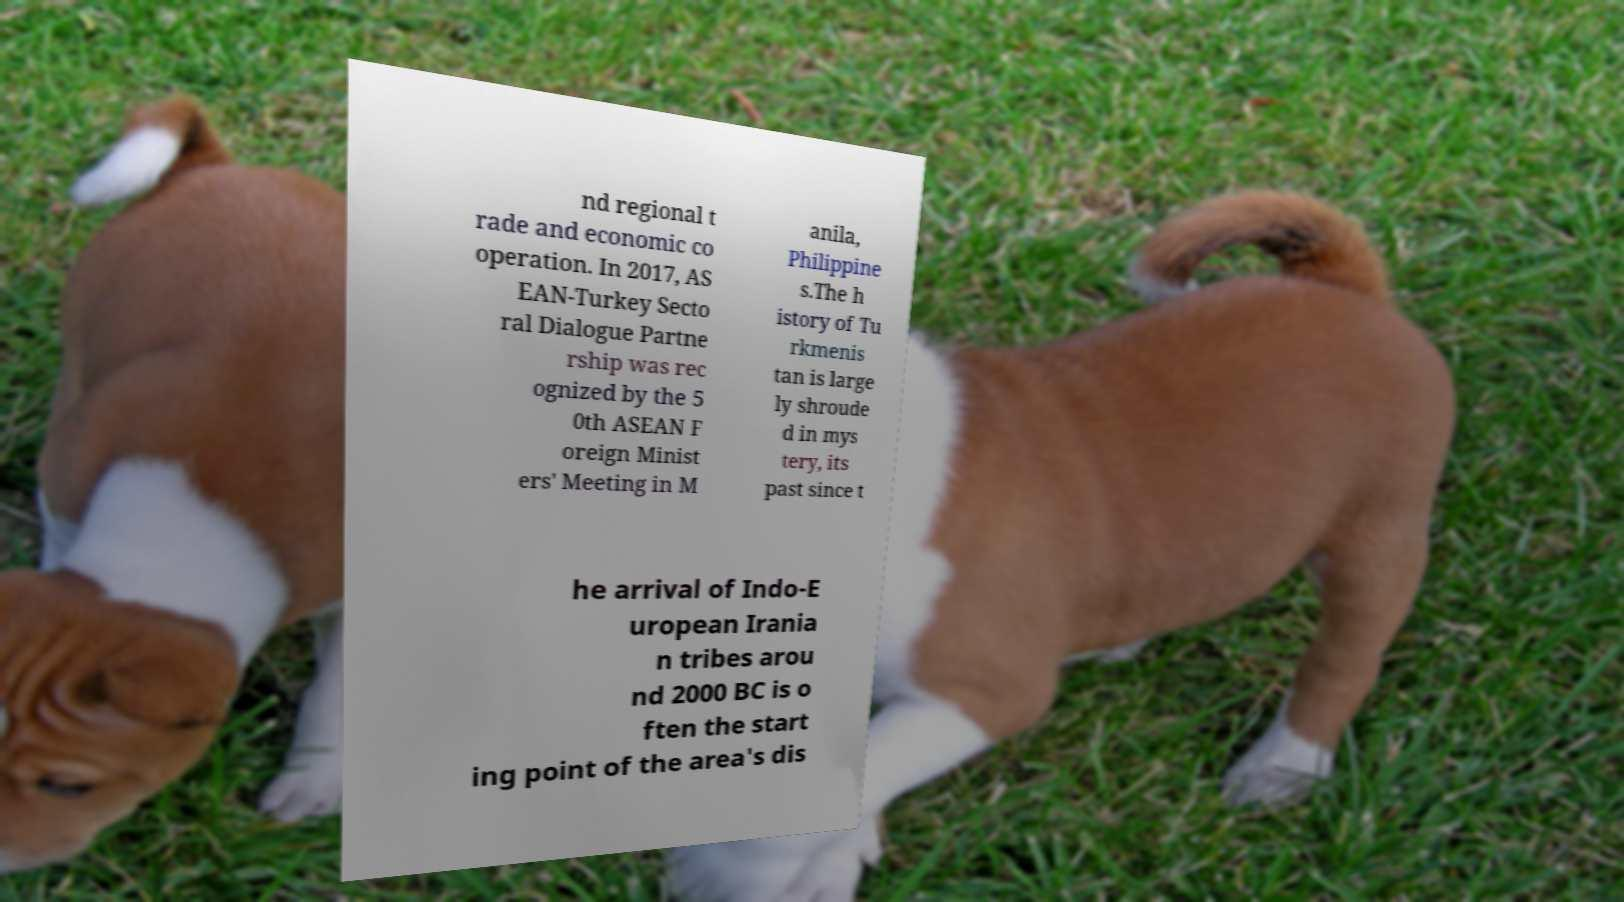For documentation purposes, I need the text within this image transcribed. Could you provide that? nd regional t rade and economic co operation. In 2017, AS EAN-Turkey Secto ral Dialogue Partne rship was rec ognized by the 5 0th ASEAN F oreign Minist ers' Meeting in M anila, Philippine s.The h istory of Tu rkmenis tan is large ly shroude d in mys tery, its past since t he arrival of Indo-E uropean Irania n tribes arou nd 2000 BC is o ften the start ing point of the area's dis 